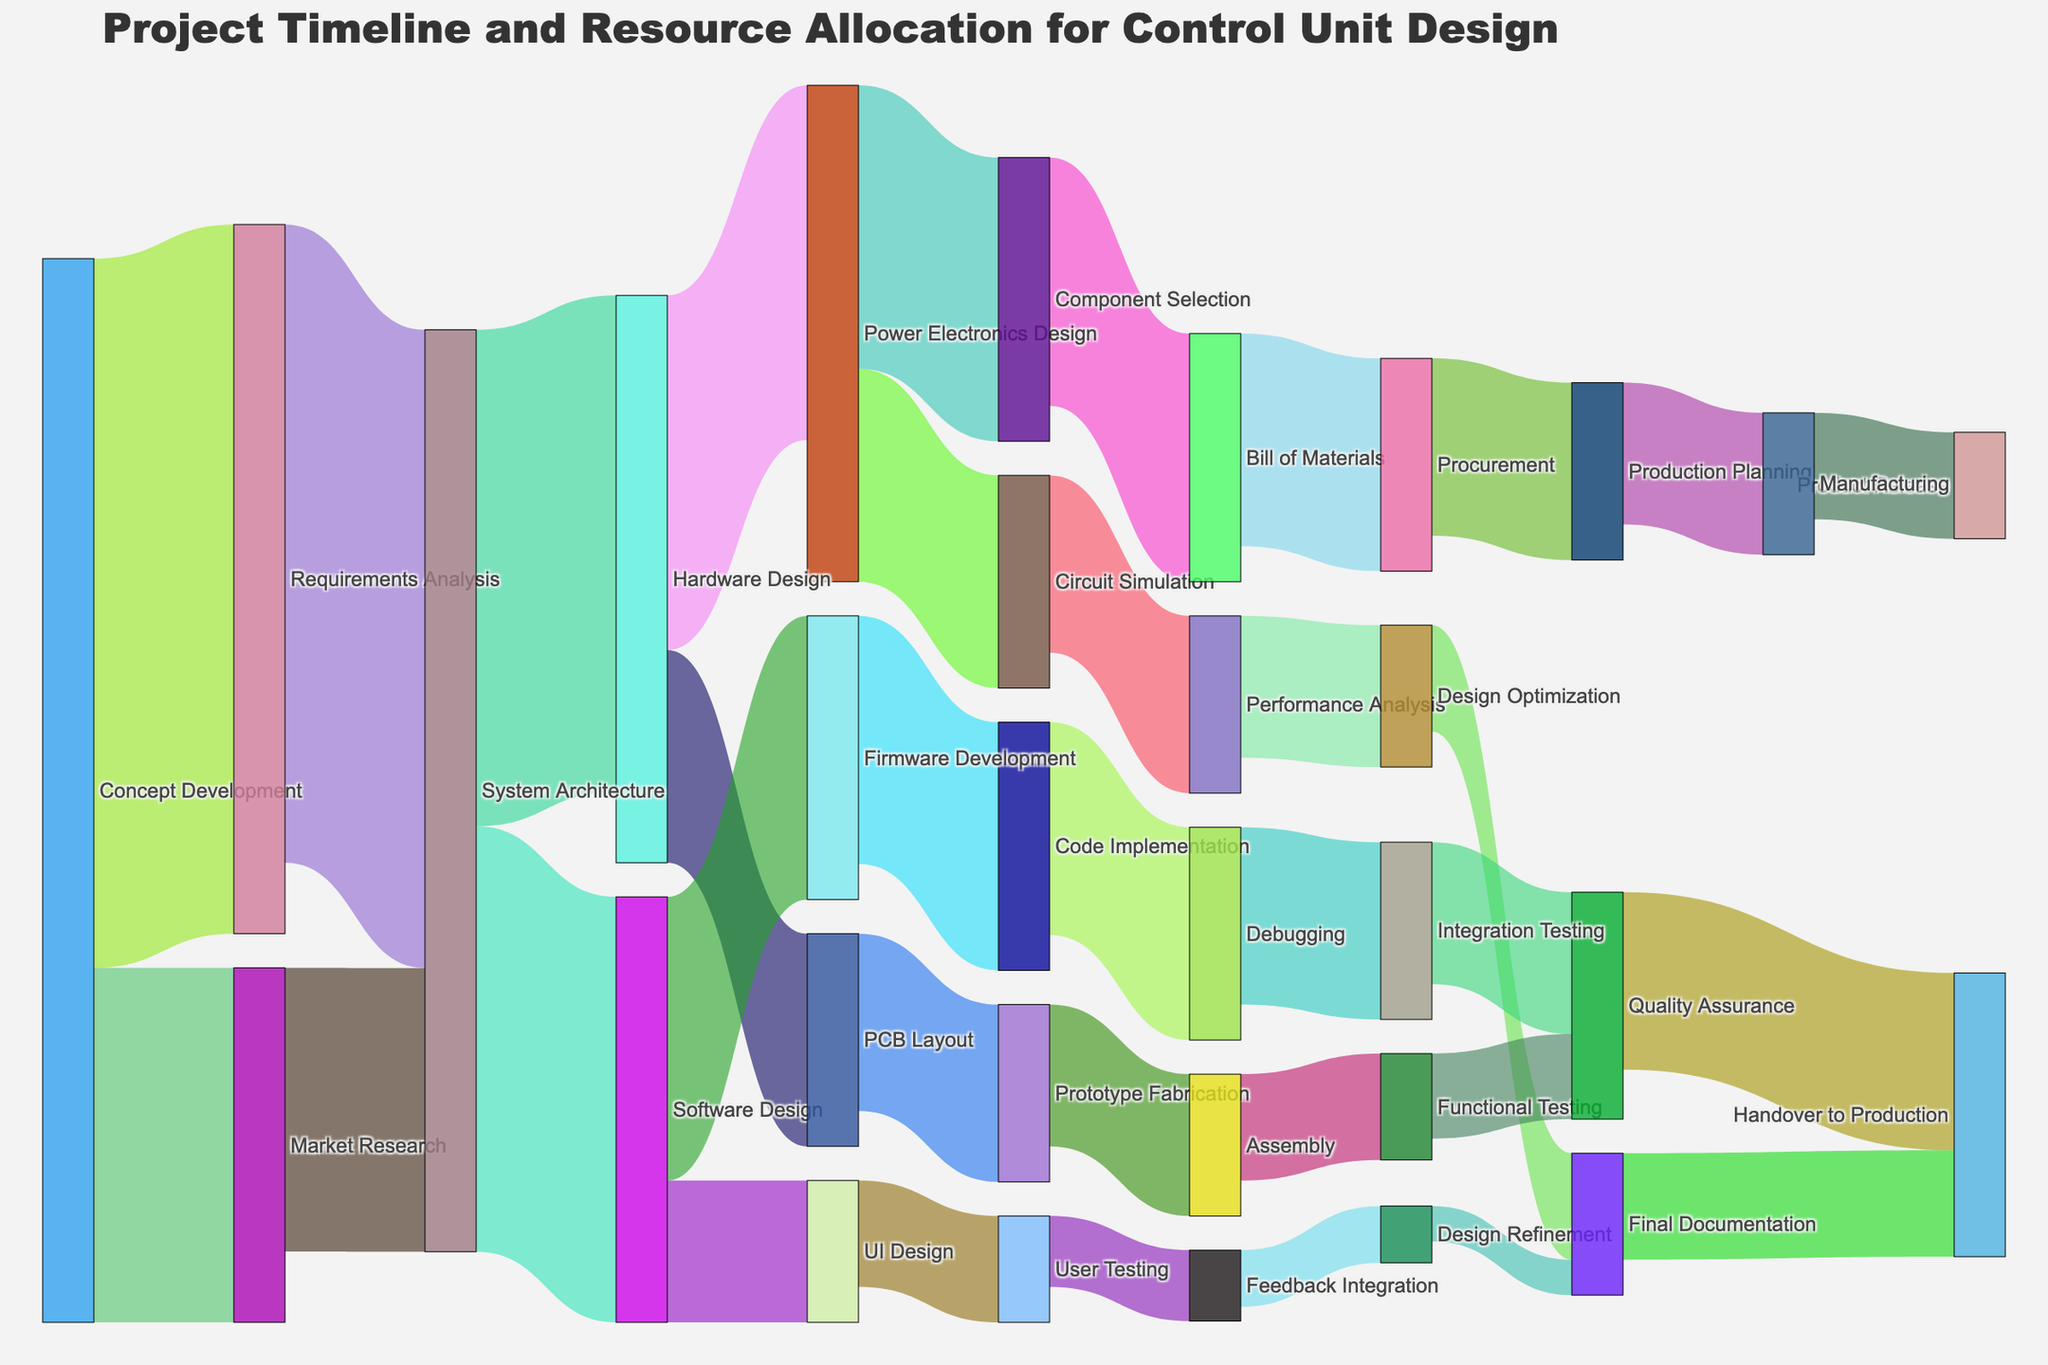What's the title of the figure? The title of the figure is prominently displayed at the top of the chart. By looking at it, we can easily determine the figure's subject.
Answer: Project Timeline and Resource Allocation for Control Unit Design How many stages begin from the 'Concept Development' phase? By examining the starting links from the 'Concept Development' node, we see that there are two outgoing links leading to 'Requirements Analysis' and 'Market Research'.
Answer: 2 What is the resource value for 'Software Design' going to 'UI Design'? By following the link from 'Software Design' to 'UI Design', the resource value displayed on the chart is 20.
Answer: 20 Which phase has more resources allocated: 'Hardware Design' or 'Software Design'? By comparing the sum of resource values going out from 'Hardware Design' (70 + 30 = 100) and 'Software Design' (40 + 20 = 60), we can see that 'Hardware Design' has more resources allocated.
Answer: Hardware Design How many phases contribute directly to the 'System Architecture' phase? By counting the incoming links to 'System Architecture', we see contributions from 'Requirements Analysis' and 'Market Research'.
Answer: 2 What's the total resource allocation flowing into 'Final Documentation'? By tracing the links flowing into 'Final Documentation' from 'Design Optimization' (15) and 'Design Refinement' (5), the total is 15 + 5 = 20.
Answer: 20 What’s the difference in resource value between 'Power Electronics Design' to 'Component Selection' and 'Power Electronics Design' to 'Circuit Simulation'? The resource value from 'Power Electronics Design' to 'Component Selection' is 40, and to 'Circuit Simulation' is 30. The difference is 40 - 30 = 10.
Answer: 10 Which path has more resources: 'Assembly' to 'Functional Testing' or 'Integration Testing' to 'Quality Assurance'? Analyzing the links, 'Assembly' to 'Functional Testing' has a value of 15, while 'Integration Testing' to 'Quality Assurance' has a value of 20. Therefore, 'Integration Testing' to 'Quality Assurance' has more resources.
Answer: Integration Testing to Quality Assurance From 'Prototype Fabrication', what is the subsequent step? The chart shows a link from 'Prototype Fabrication' leading directly to 'Assembly'. This identifies 'Assembly' as the next step.
Answer: Assembly Which phase does the project end with? By following the final outgoing links in the chart, we see that the final phase indicated is 'Product Release', which comes after 'Manufacturing'.
Answer: Product Release 